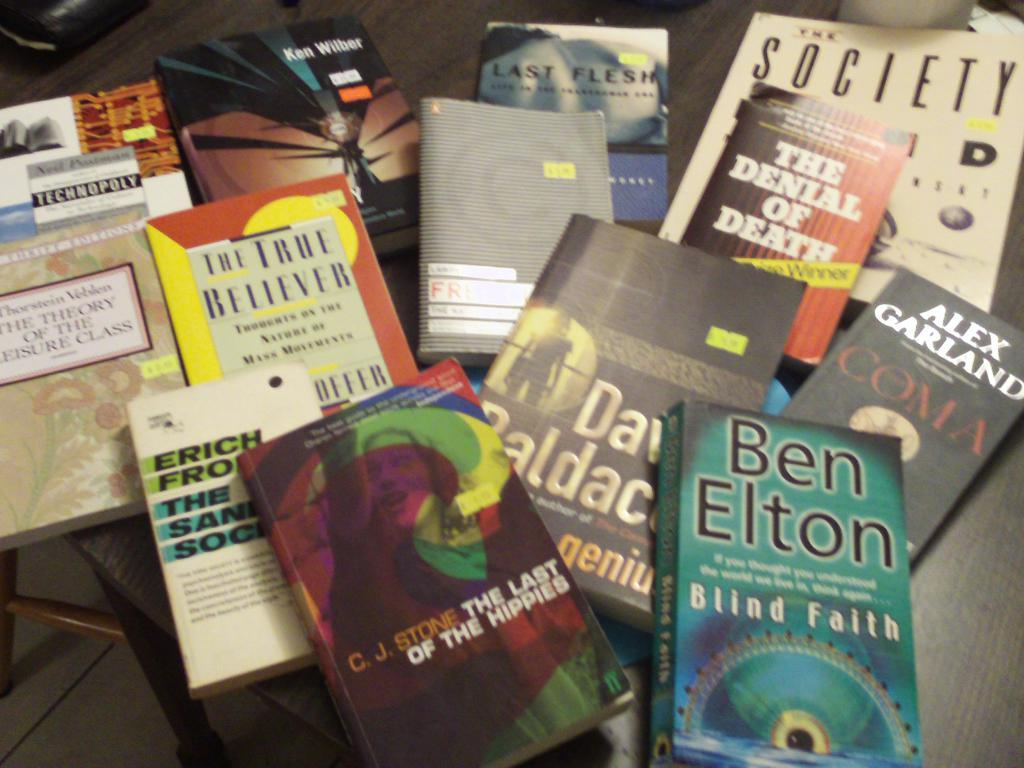<image>
Present a compact description of the photo's key features. the name Ben Elton is on the blue book 